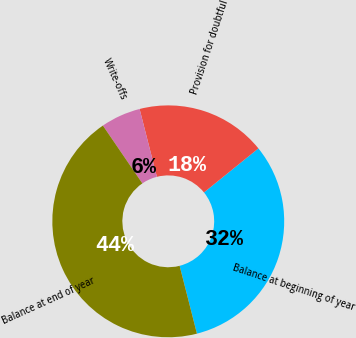<chart> <loc_0><loc_0><loc_500><loc_500><pie_chart><fcel>Balance at beginning of year<fcel>Provision for doubtful<fcel>Write-offs<fcel>Balance at end of year<nl><fcel>31.85%<fcel>18.15%<fcel>5.56%<fcel>44.44%<nl></chart> 